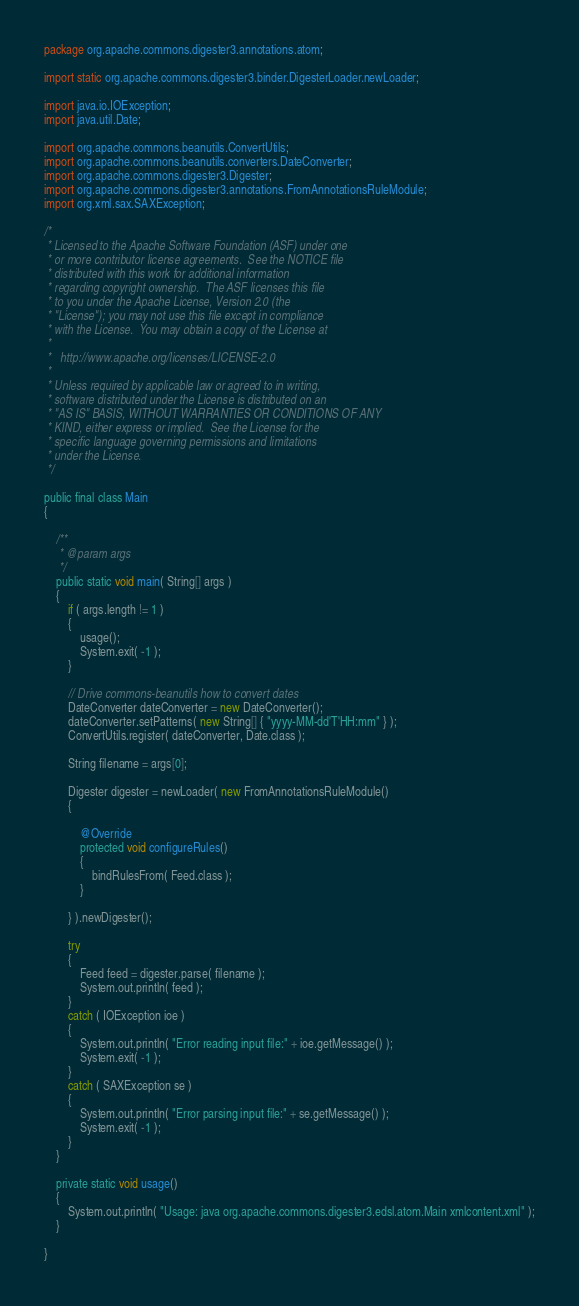<code> <loc_0><loc_0><loc_500><loc_500><_Java_>package org.apache.commons.digester3.annotations.atom;

import static org.apache.commons.digester3.binder.DigesterLoader.newLoader;

import java.io.IOException;
import java.util.Date;

import org.apache.commons.beanutils.ConvertUtils;
import org.apache.commons.beanutils.converters.DateConverter;
import org.apache.commons.digester3.Digester;
import org.apache.commons.digester3.annotations.FromAnnotationsRuleModule;
import org.xml.sax.SAXException;

/*
 * Licensed to the Apache Software Foundation (ASF) under one
 * or more contributor license agreements.  See the NOTICE file
 * distributed with this work for additional information
 * regarding copyright ownership.  The ASF licenses this file
 * to you under the Apache License, Version 2.0 (the
 * "License"); you may not use this file except in compliance
 * with the License.  You may obtain a copy of the License at
 *
 *   http://www.apache.org/licenses/LICENSE-2.0
 *
 * Unless required by applicable law or agreed to in writing,
 * software distributed under the License is distributed on an
 * "AS IS" BASIS, WITHOUT WARRANTIES OR CONDITIONS OF ANY
 * KIND, either express or implied.  See the License for the
 * specific language governing permissions and limitations
 * under the License.
 */

public final class Main
{

    /**
     * @param args
     */
    public static void main( String[] args )
    {
        if ( args.length != 1 )
        {
            usage();
            System.exit( -1 );
        }

        // Drive commons-beanutils how to convert dates
        DateConverter dateConverter = new DateConverter();
        dateConverter.setPatterns( new String[] { "yyyy-MM-dd'T'HH:mm" } );
        ConvertUtils.register( dateConverter, Date.class );

        String filename = args[0];

        Digester digester = newLoader( new FromAnnotationsRuleModule()
        {

            @Override
            protected void configureRules()
            {
                bindRulesFrom( Feed.class );
            }

        } ).newDigester();

        try
        {
            Feed feed = digester.parse( filename );
            System.out.println( feed );
        }
        catch ( IOException ioe )
        {
            System.out.println( "Error reading input file:" + ioe.getMessage() );
            System.exit( -1 );
        }
        catch ( SAXException se )
        {
            System.out.println( "Error parsing input file:" + se.getMessage() );
            System.exit( -1 );
        }
    }

    private static void usage()
    {
        System.out.println( "Usage: java org.apache.commons.digester3.edsl.atom.Main xmlcontent.xml" );
    }

}
</code> 